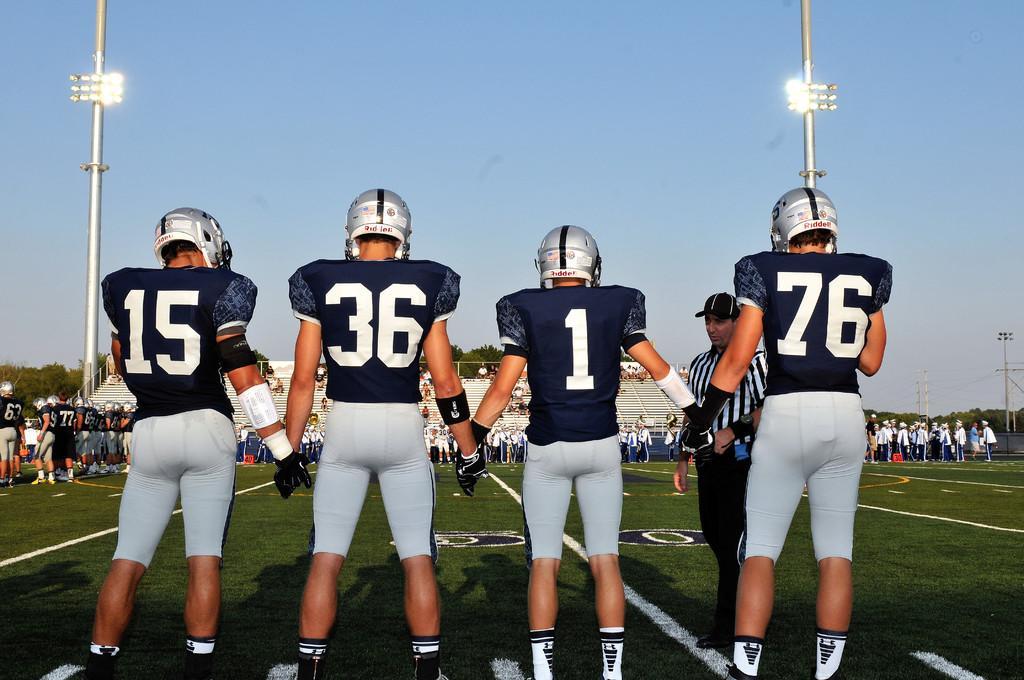How would you summarize this image in a sentence or two? In this picture I can see there are four players standing and they are wearing jerseys, pants and helmets. In the backdrop there are few people standing and there are few poles with lights and there are trees at right and left sides. The sky is clear. 